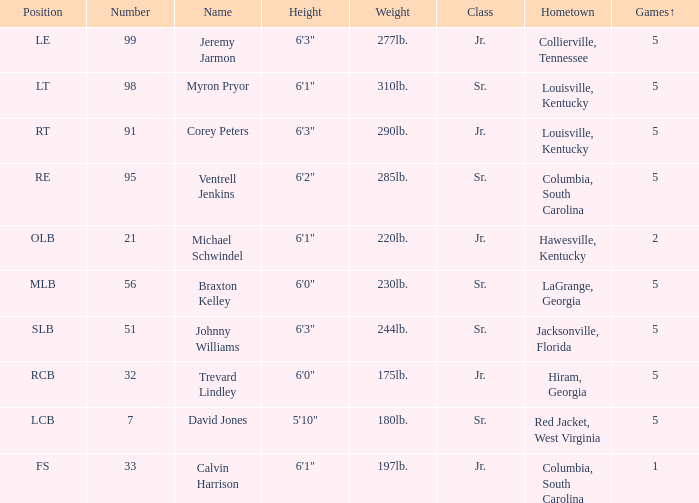What was trevard lindley's digit? 32.0. 